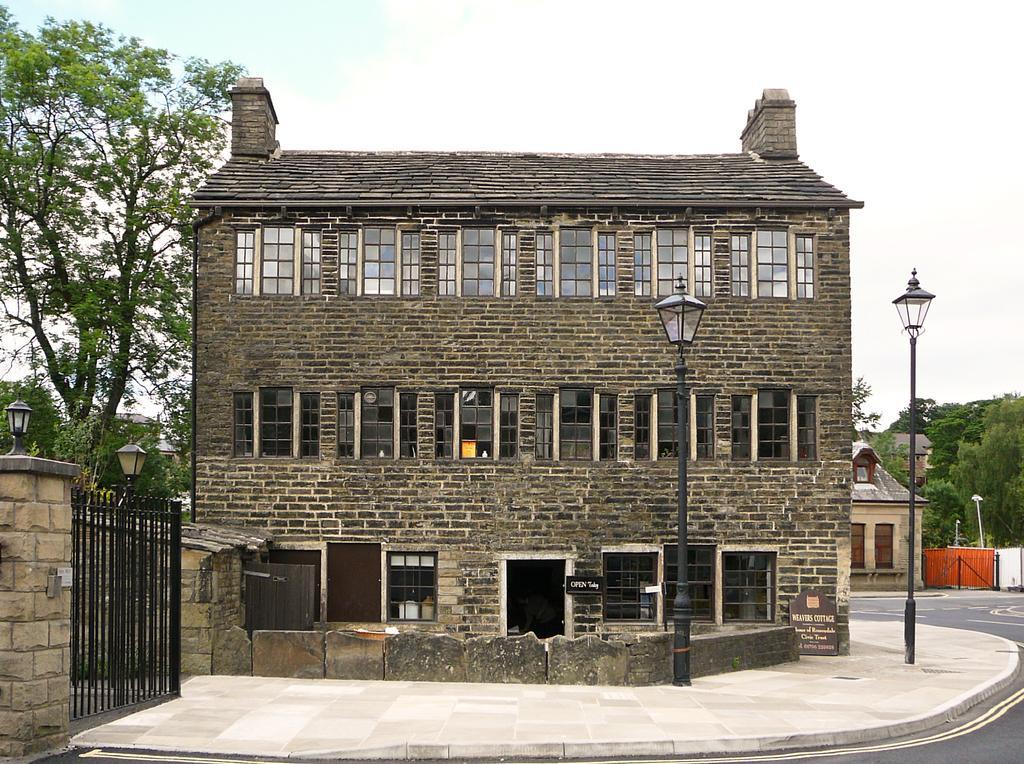How would you summarize this image in a sentence or two? In this image we can see a few buildings, there are some trees, gates, doors, windows, poles and lights, in the background we can see the sky. 